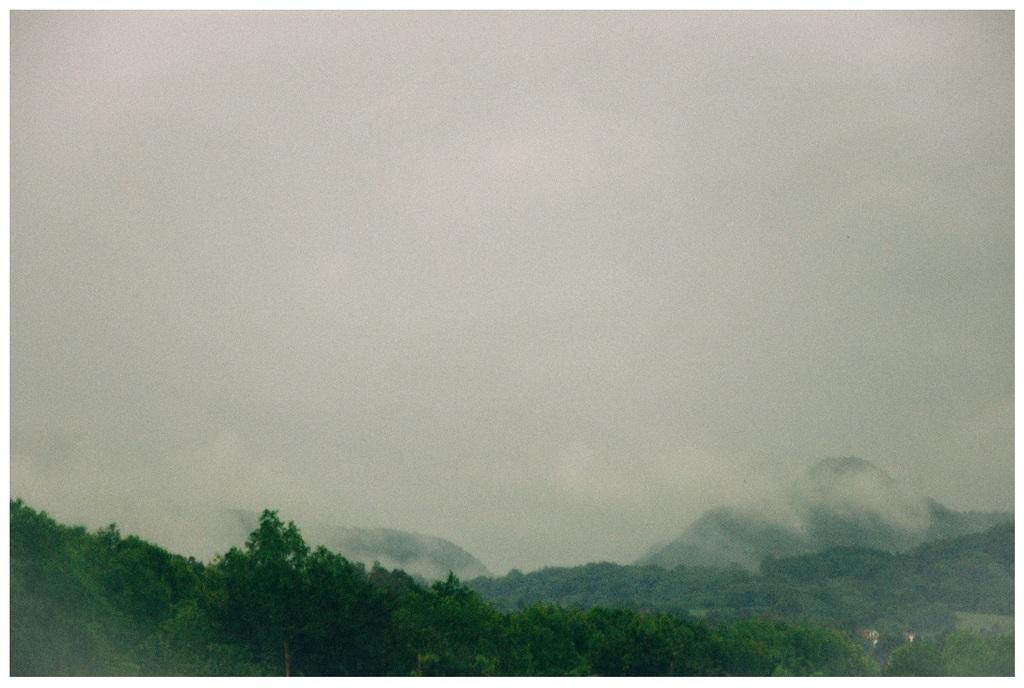What type of natural features can be seen in the image? There are trees and mountains in the image. What part of the natural environment is visible in the image? The sky is visible in the image. What can be observed in the sky in the image? There are clouds in the image. Can you tell me how many drawers are visible in the image? There are no drawers present in the image; it features natural elements such as trees, mountains, sky, and clouds. 